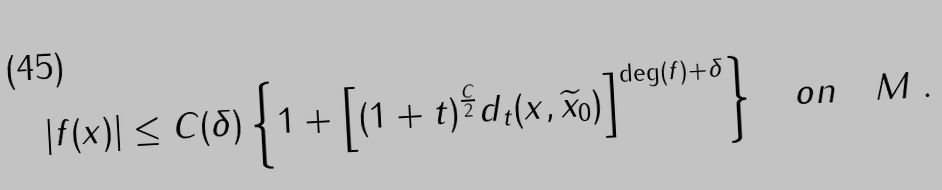Convert formula to latex. <formula><loc_0><loc_0><loc_500><loc_500>\left | f ( x ) \right | \leq C ( \delta ) \left \{ 1 + \left [ ( 1 + t ) ^ { \frac { C } { 2 } } d _ { t } ( x , \widetilde { x } _ { 0 } ) \right ] ^ { \deg ( f ) + \delta } \right \} \quad o n \quad M \ .</formula> 